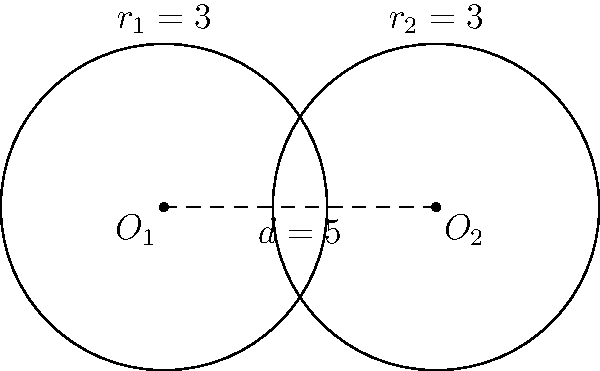In your dojo, you have two circular sparring zones represented by the circles in the diagram. Both circles have a radius of 3 meters, and their centers are 5 meters apart. Are these sparring zones congruent? If so, explain why. To determine if the two circular sparring zones are congruent, we need to compare their properties:

1. Radius: Both circles have the same radius, $r_1 = r_2 = 3$ meters.

2. Center points: The centers are different, located 5 meters apart. However, the location of the center points does not affect congruence.

3. Shape: Both are perfect circles.

4. Size: The size of a circle is determined by its radius. Since both radii are equal, the sizes are the same.

Two geometric figures are considered congruent if they have the same shape and size. In the case of circles, this means they must have the same radius.

Since both sparring zones have the same radius (3 meters) and are both circles, they are congruent.

The distance between the centers (5 meters) does not affect the congruence of the circles themselves, as congruence is about the shape and size of the individual figures, not their relative positions.
Answer: Yes, congruent (same radius of 3 meters). 